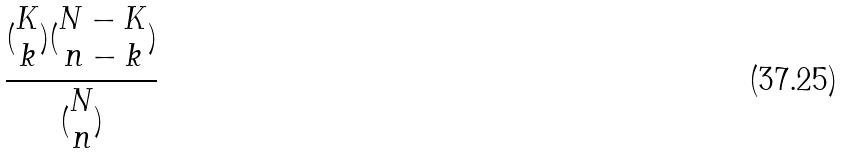Convert formula to latex. <formula><loc_0><loc_0><loc_500><loc_500>\frac { ( \begin{matrix} K \\ k \end{matrix} ) ( \begin{matrix} N - K \\ n - k \end{matrix} ) } { ( \begin{matrix} N \\ n \end{matrix} ) }</formula> 